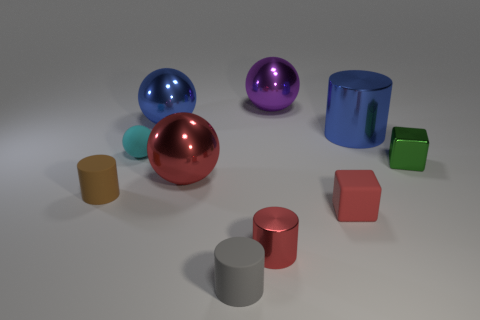How is lighting affecting the appearance of the objects in the image? The lighting in the image creates soft shadows on one side of the objects, indicating a light source above and to the right. It enhances the three-dimensional quality of the objects and gives the scene a sense of depth. Does the lighting create any particular mood or atmosphere? Yes, the soft shadows and subtle highlights contribute to a calm and controlled atmosphere, and the diffused light gives the scene a peaceful and clean aesthetic. 